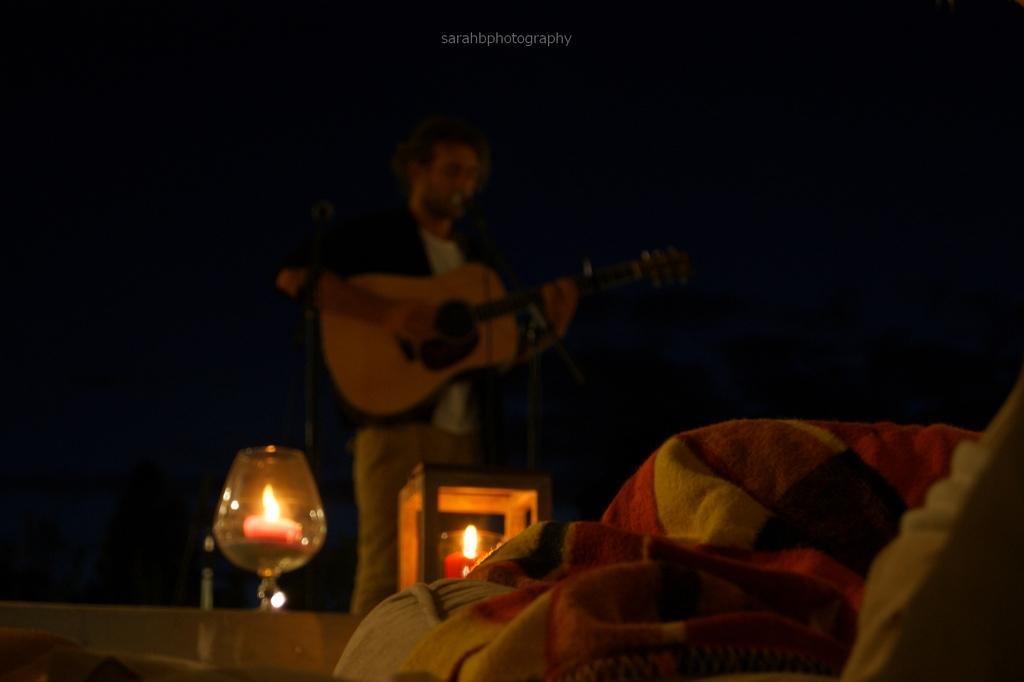Can you describe this image briefly? Background is very dark. Here we can see a man standing in front of a mike , singing and playing guitar. Here we can see candles and a glass. This is a blanket and a pillow. 